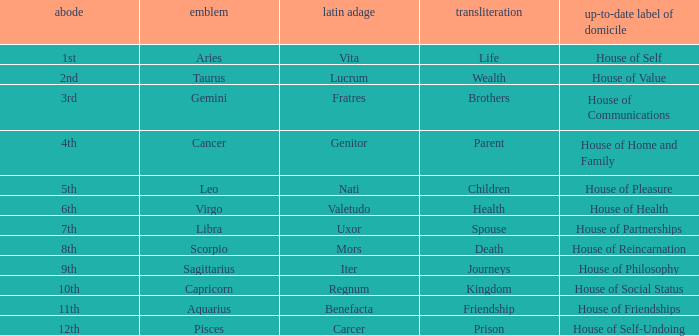Which sign has a modern house title of House of Partnerships? Libra. 